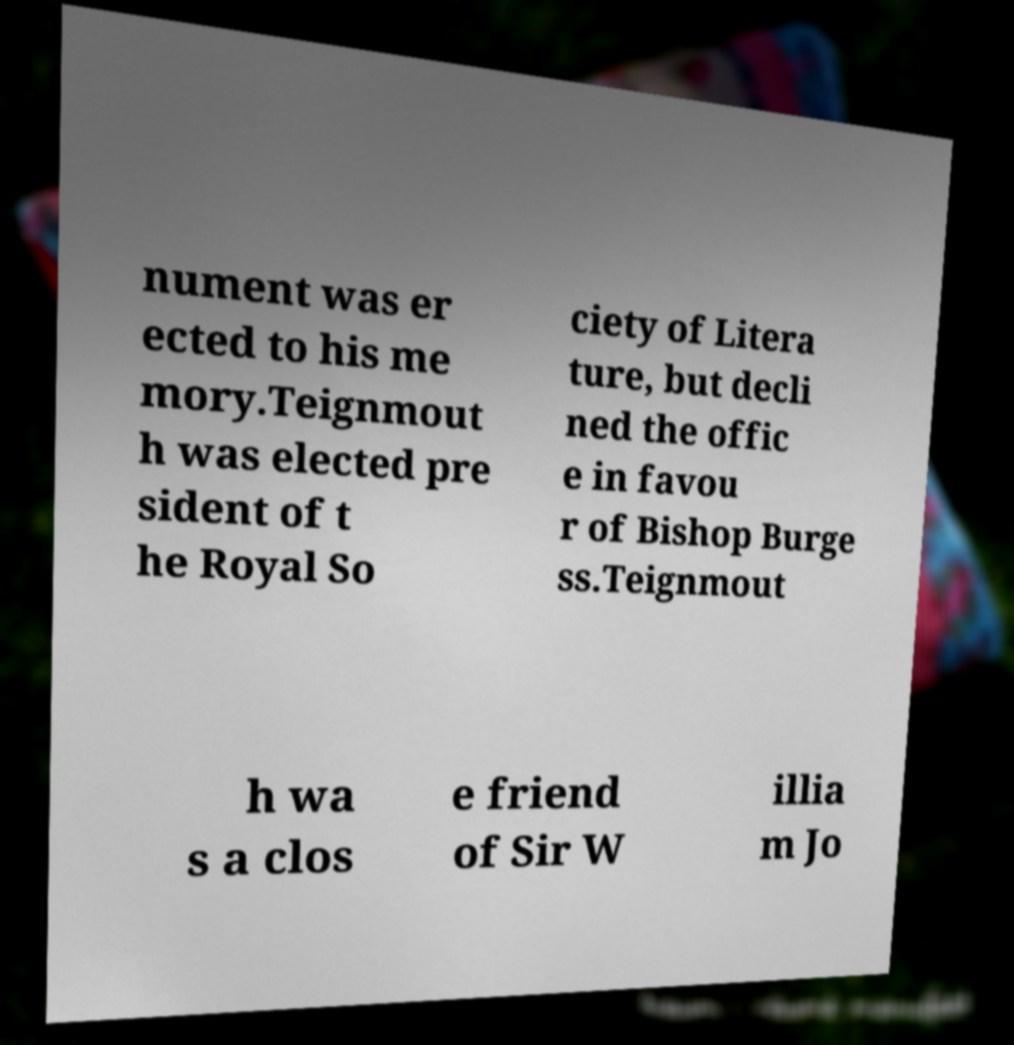For documentation purposes, I need the text within this image transcribed. Could you provide that? nument was er ected to his me mory.Teignmout h was elected pre sident of t he Royal So ciety of Litera ture, but decli ned the offic e in favou r of Bishop Burge ss.Teignmout h wa s a clos e friend of Sir W illia m Jo 